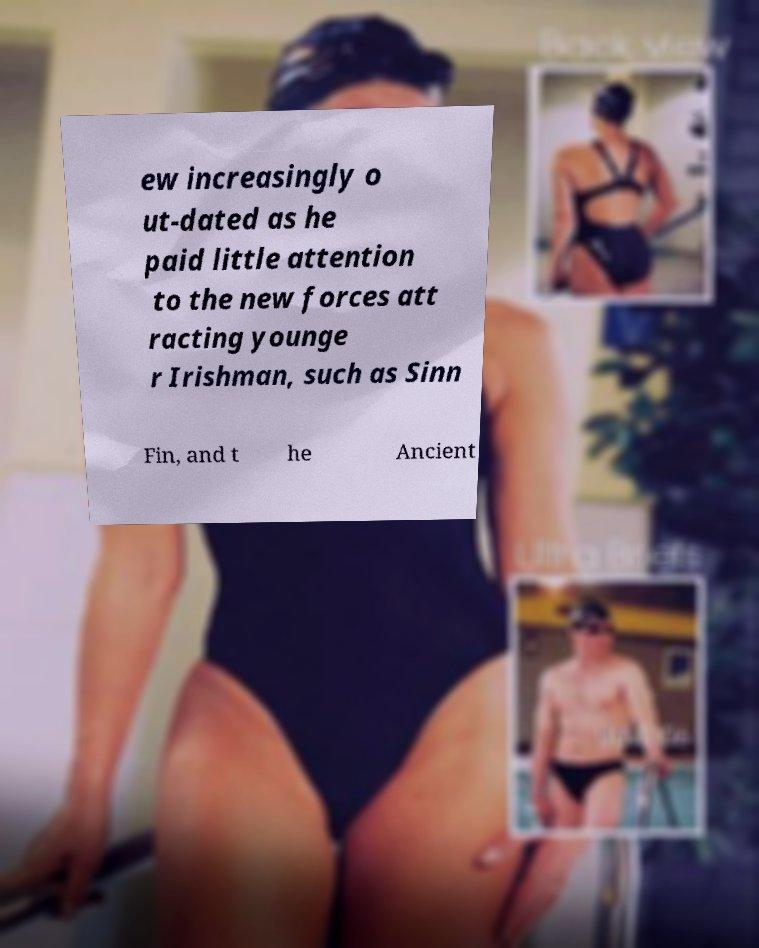Can you accurately transcribe the text from the provided image for me? ew increasingly o ut-dated as he paid little attention to the new forces att racting younge r Irishman, such as Sinn Fin, and t he Ancient 